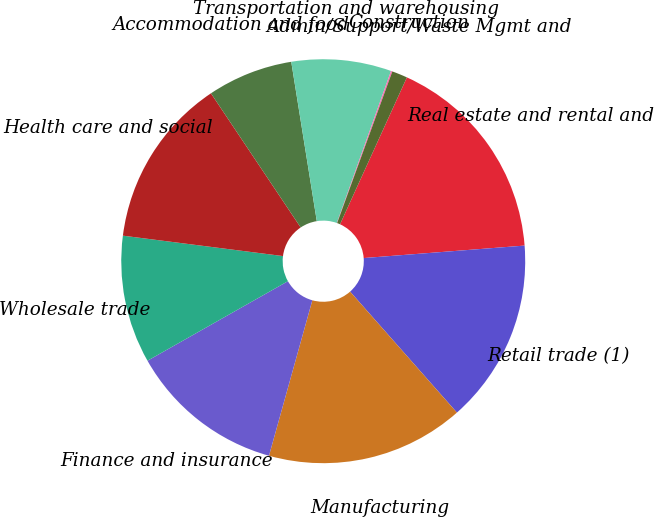<chart> <loc_0><loc_0><loc_500><loc_500><pie_chart><fcel>Real estate and rental and<fcel>Retail trade (1)<fcel>Manufacturing<fcel>Finance and insurance<fcel>Wholesale trade<fcel>Health care and social<fcel>Accommodation and food<fcel>Transportation and warehousing<fcel>Construction<fcel>Admin/Support/Waste Mgmt and<nl><fcel>16.97%<fcel>14.72%<fcel>15.84%<fcel>12.47%<fcel>10.22%<fcel>13.6%<fcel>6.85%<fcel>7.98%<fcel>0.11%<fcel>1.24%<nl></chart> 